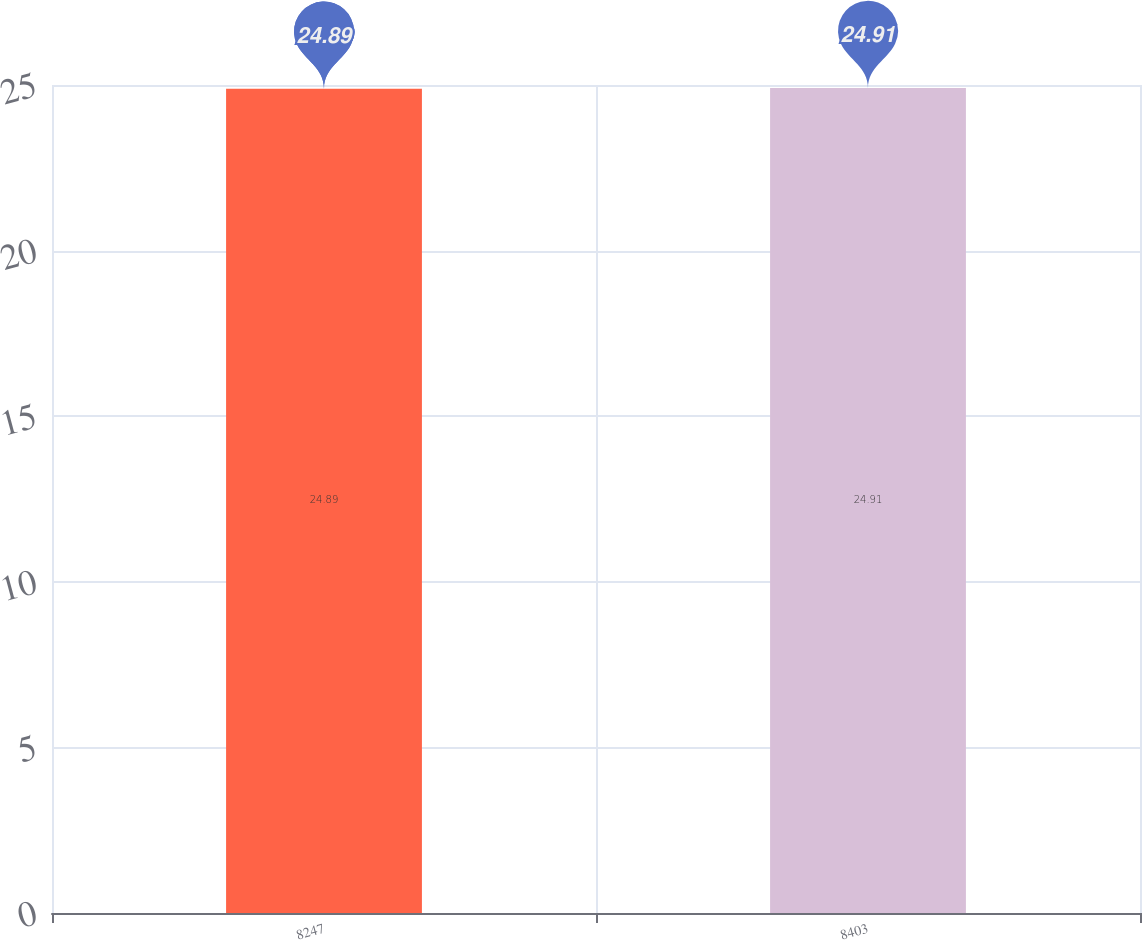Convert chart. <chart><loc_0><loc_0><loc_500><loc_500><bar_chart><fcel>8247<fcel>8403<nl><fcel>24.89<fcel>24.91<nl></chart> 